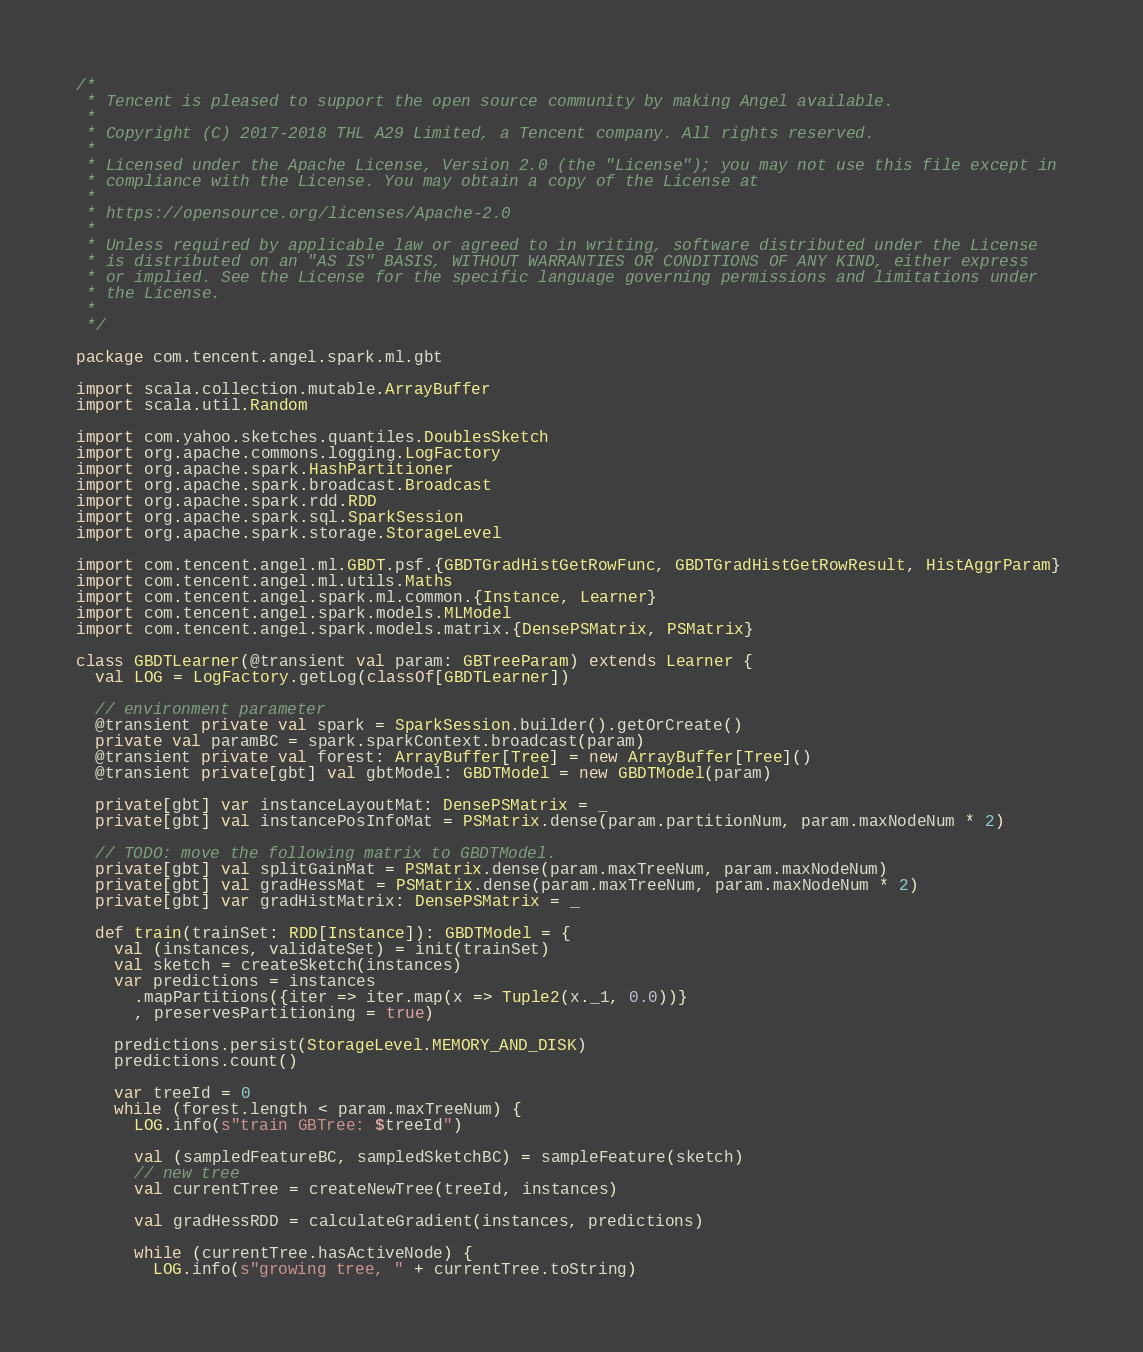Convert code to text. <code><loc_0><loc_0><loc_500><loc_500><_Scala_>/*
 * Tencent is pleased to support the open source community by making Angel available.
 *
 * Copyright (C) 2017-2018 THL A29 Limited, a Tencent company. All rights reserved.
 *
 * Licensed under the Apache License, Version 2.0 (the "License"); you may not use this file except in 
 * compliance with the License. You may obtain a copy of the License at
 *
 * https://opensource.org/licenses/Apache-2.0
 *
 * Unless required by applicable law or agreed to in writing, software distributed under the License
 * is distributed on an "AS IS" BASIS, WITHOUT WARRANTIES OR CONDITIONS OF ANY KIND, either express
 * or implied. See the License for the specific language governing permissions and limitations under
 * the License.
 *
 */

package com.tencent.angel.spark.ml.gbt

import scala.collection.mutable.ArrayBuffer
import scala.util.Random

import com.yahoo.sketches.quantiles.DoublesSketch
import org.apache.commons.logging.LogFactory
import org.apache.spark.HashPartitioner
import org.apache.spark.broadcast.Broadcast
import org.apache.spark.rdd.RDD
import org.apache.spark.sql.SparkSession
import org.apache.spark.storage.StorageLevel

import com.tencent.angel.ml.GBDT.psf.{GBDTGradHistGetRowFunc, GBDTGradHistGetRowResult, HistAggrParam}
import com.tencent.angel.ml.utils.Maths
import com.tencent.angel.spark.ml.common.{Instance, Learner}
import com.tencent.angel.spark.models.MLModel
import com.tencent.angel.spark.models.matrix.{DensePSMatrix, PSMatrix}

class GBDTLearner(@transient val param: GBTreeParam) extends Learner {
  val LOG = LogFactory.getLog(classOf[GBDTLearner])

  // environment parameter
  @transient private val spark = SparkSession.builder().getOrCreate()
  private val paramBC = spark.sparkContext.broadcast(param)
  @transient private val forest: ArrayBuffer[Tree] = new ArrayBuffer[Tree]()
  @transient private[gbt] val gbtModel: GBDTModel = new GBDTModel(param)

  private[gbt] var instanceLayoutMat: DensePSMatrix = _
  private[gbt] val instancePosInfoMat = PSMatrix.dense(param.partitionNum, param.maxNodeNum * 2)

  // TODO: move the following matrix to GBDTModel.
  private[gbt] val splitGainMat = PSMatrix.dense(param.maxTreeNum, param.maxNodeNum)
  private[gbt] val gradHessMat = PSMatrix.dense(param.maxTreeNum, param.maxNodeNum * 2)
  private[gbt] var gradHistMatrix: DensePSMatrix = _

  def train(trainSet: RDD[Instance]): GBDTModel = {
    val (instances, validateSet) = init(trainSet)
    val sketch = createSketch(instances)
    var predictions = instances
      .mapPartitions({iter => iter.map(x => Tuple2(x._1, 0.0))}
      , preservesPartitioning = true)

    predictions.persist(StorageLevel.MEMORY_AND_DISK)
    predictions.count()

    var treeId = 0
    while (forest.length < param.maxTreeNum) {
      LOG.info(s"train GBTree: $treeId")

      val (sampledFeatureBC, sampledSketchBC) = sampleFeature(sketch)
      // new tree
      val currentTree = createNewTree(treeId, instances)

      val gradHessRDD = calculateGradient(instances, predictions)

      while (currentTree.hasActiveNode) {
        LOG.info(s"growing tree, " + currentTree.toString)</code> 